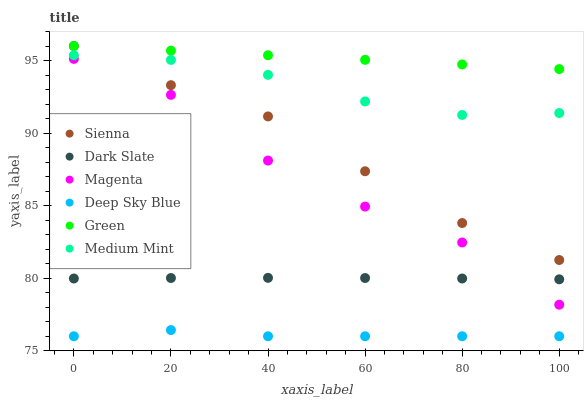Does Deep Sky Blue have the minimum area under the curve?
Answer yes or no. Yes. Does Green have the maximum area under the curve?
Answer yes or no. Yes. Does Sienna have the minimum area under the curve?
Answer yes or no. No. Does Sienna have the maximum area under the curve?
Answer yes or no. No. Is Green the smoothest?
Answer yes or no. Yes. Is Magenta the roughest?
Answer yes or no. Yes. Is Sienna the smoothest?
Answer yes or no. No. Is Sienna the roughest?
Answer yes or no. No. Does Deep Sky Blue have the lowest value?
Answer yes or no. Yes. Does Sienna have the lowest value?
Answer yes or no. No. Does Green have the highest value?
Answer yes or no. Yes. Does Dark Slate have the highest value?
Answer yes or no. No. Is Deep Sky Blue less than Sienna?
Answer yes or no. Yes. Is Green greater than Dark Slate?
Answer yes or no. Yes. Does Magenta intersect Dark Slate?
Answer yes or no. Yes. Is Magenta less than Dark Slate?
Answer yes or no. No. Is Magenta greater than Dark Slate?
Answer yes or no. No. Does Deep Sky Blue intersect Sienna?
Answer yes or no. No. 